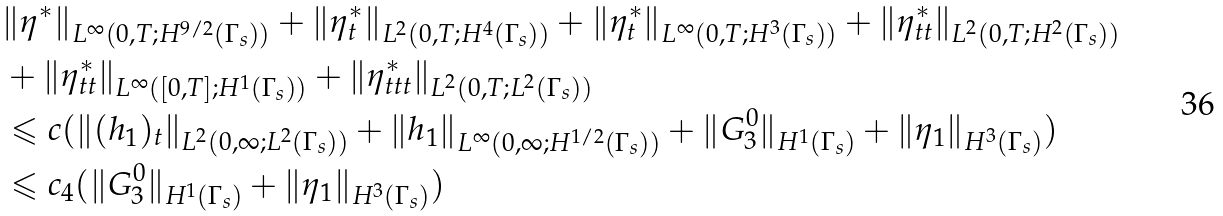Convert formula to latex. <formula><loc_0><loc_0><loc_500><loc_500>& \| \eta ^ { * } \| _ { L ^ { \infty } ( 0 , T ; H ^ { 9 / 2 } ( \Gamma _ { s } ) ) } + \| \eta _ { t } ^ { * } \| _ { L ^ { 2 } ( 0 , T ; H ^ { 4 } ( \Gamma _ { s } ) ) } + \| \eta _ { t } ^ { * } \| _ { L ^ { \infty } ( 0 , T ; H ^ { 3 } ( \Gamma _ { s } ) ) } + \| \eta _ { t t } ^ { * } \| _ { L ^ { 2 } ( 0 , T ; H ^ { 2 } ( \Gamma _ { s } ) ) } \\ & + \| \eta _ { t t } ^ { * } \| _ { L ^ { \infty } ( [ 0 , T ] ; H ^ { 1 } ( \Gamma _ { s } ) ) } + \| \eta _ { t t t } ^ { * } \| _ { L ^ { 2 } ( 0 , T ; L ^ { 2 } ( \Gamma _ { s } ) ) } \\ & \leqslant c ( \| ( h _ { 1 } ) _ { t } \| _ { L ^ { 2 } ( 0 , \infty ; L ^ { 2 } ( \Gamma _ { s } ) ) } + \| h _ { 1 } \| _ { L ^ { \infty } ( 0 , \infty ; H ^ { 1 / 2 } ( \Gamma _ { s } ) ) } + \| G _ { 3 } ^ { 0 } \| _ { H ^ { 1 } ( \Gamma _ { s } ) } + \| \eta _ { 1 } \| _ { H ^ { 3 } ( \Gamma _ { s } ) } ) \\ & \leqslant c _ { 4 } ( \| G _ { 3 } ^ { 0 } \| _ { H ^ { 1 } ( \Gamma _ { s } ) } + \| \eta _ { 1 } \| _ { H ^ { 3 } ( \Gamma _ { s } ) } )</formula> 